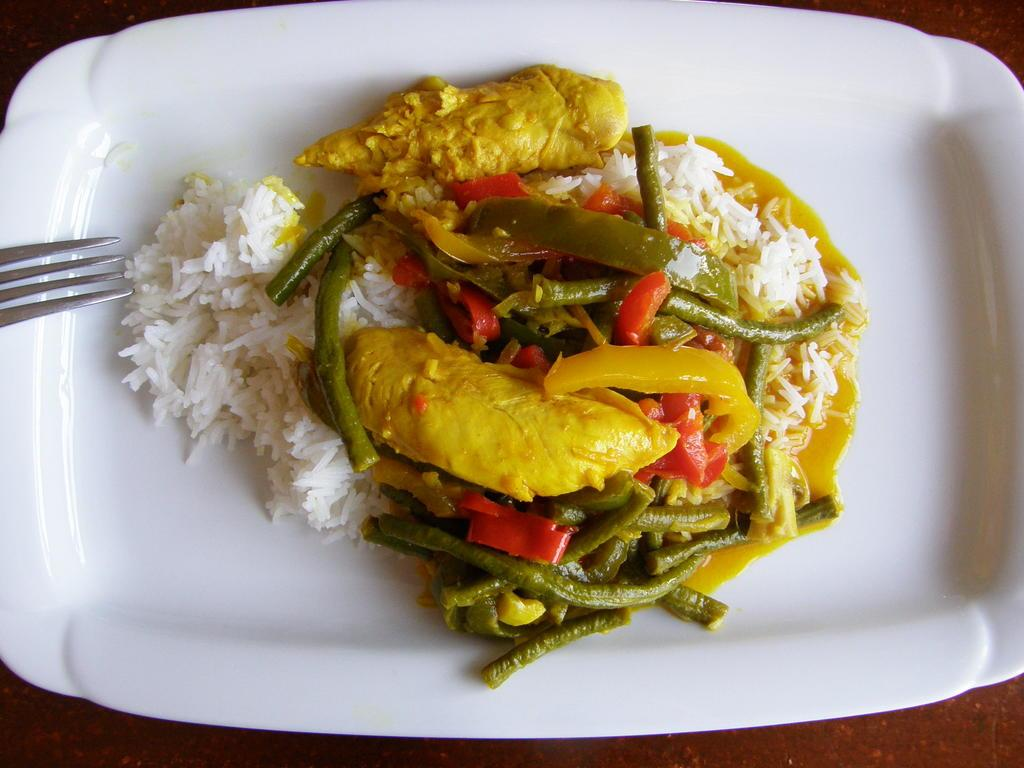What is present on the plate in the image? There is rice in the image. What utensil can be seen in the image? There is a fork in the image. What type of food is visible on the plate? There is there any meat? What else can be seen on the table besides the plate and fork? There are food items on the table. Can you describe the setting where the image might have been taken? The image may have been taken in a room. What rhythm is the meat following in the image? There is no rhythm associated with the meat in the image; it is simply a food item on the plate. What topic are the food items discussing in the image? Food items do not have the ability to talk or discuss topics, so this question cannot be answered. 